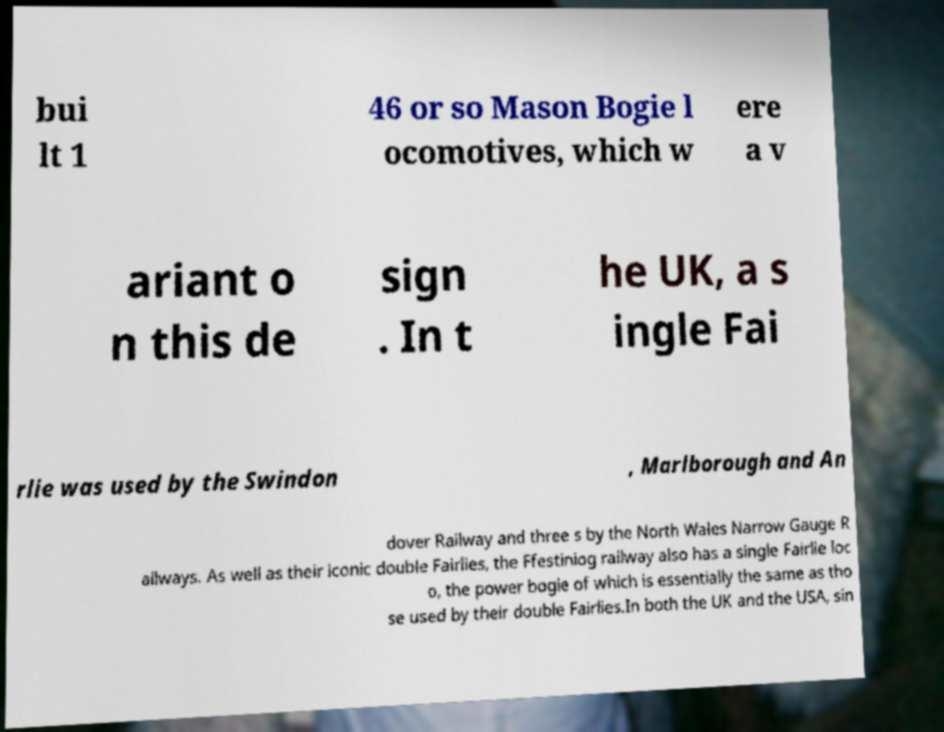Please read and relay the text visible in this image. What does it say? bui lt 1 46 or so Mason Bogie l ocomotives, which w ere a v ariant o n this de sign . In t he UK, a s ingle Fai rlie was used by the Swindon , Marlborough and An dover Railway and three s by the North Wales Narrow Gauge R ailways. As well as their iconic double Fairlies, the Ffestiniog railway also has a single Fairlie loc o, the power bogie of which is essentially the same as tho se used by their double Fairlies.In both the UK and the USA, sin 